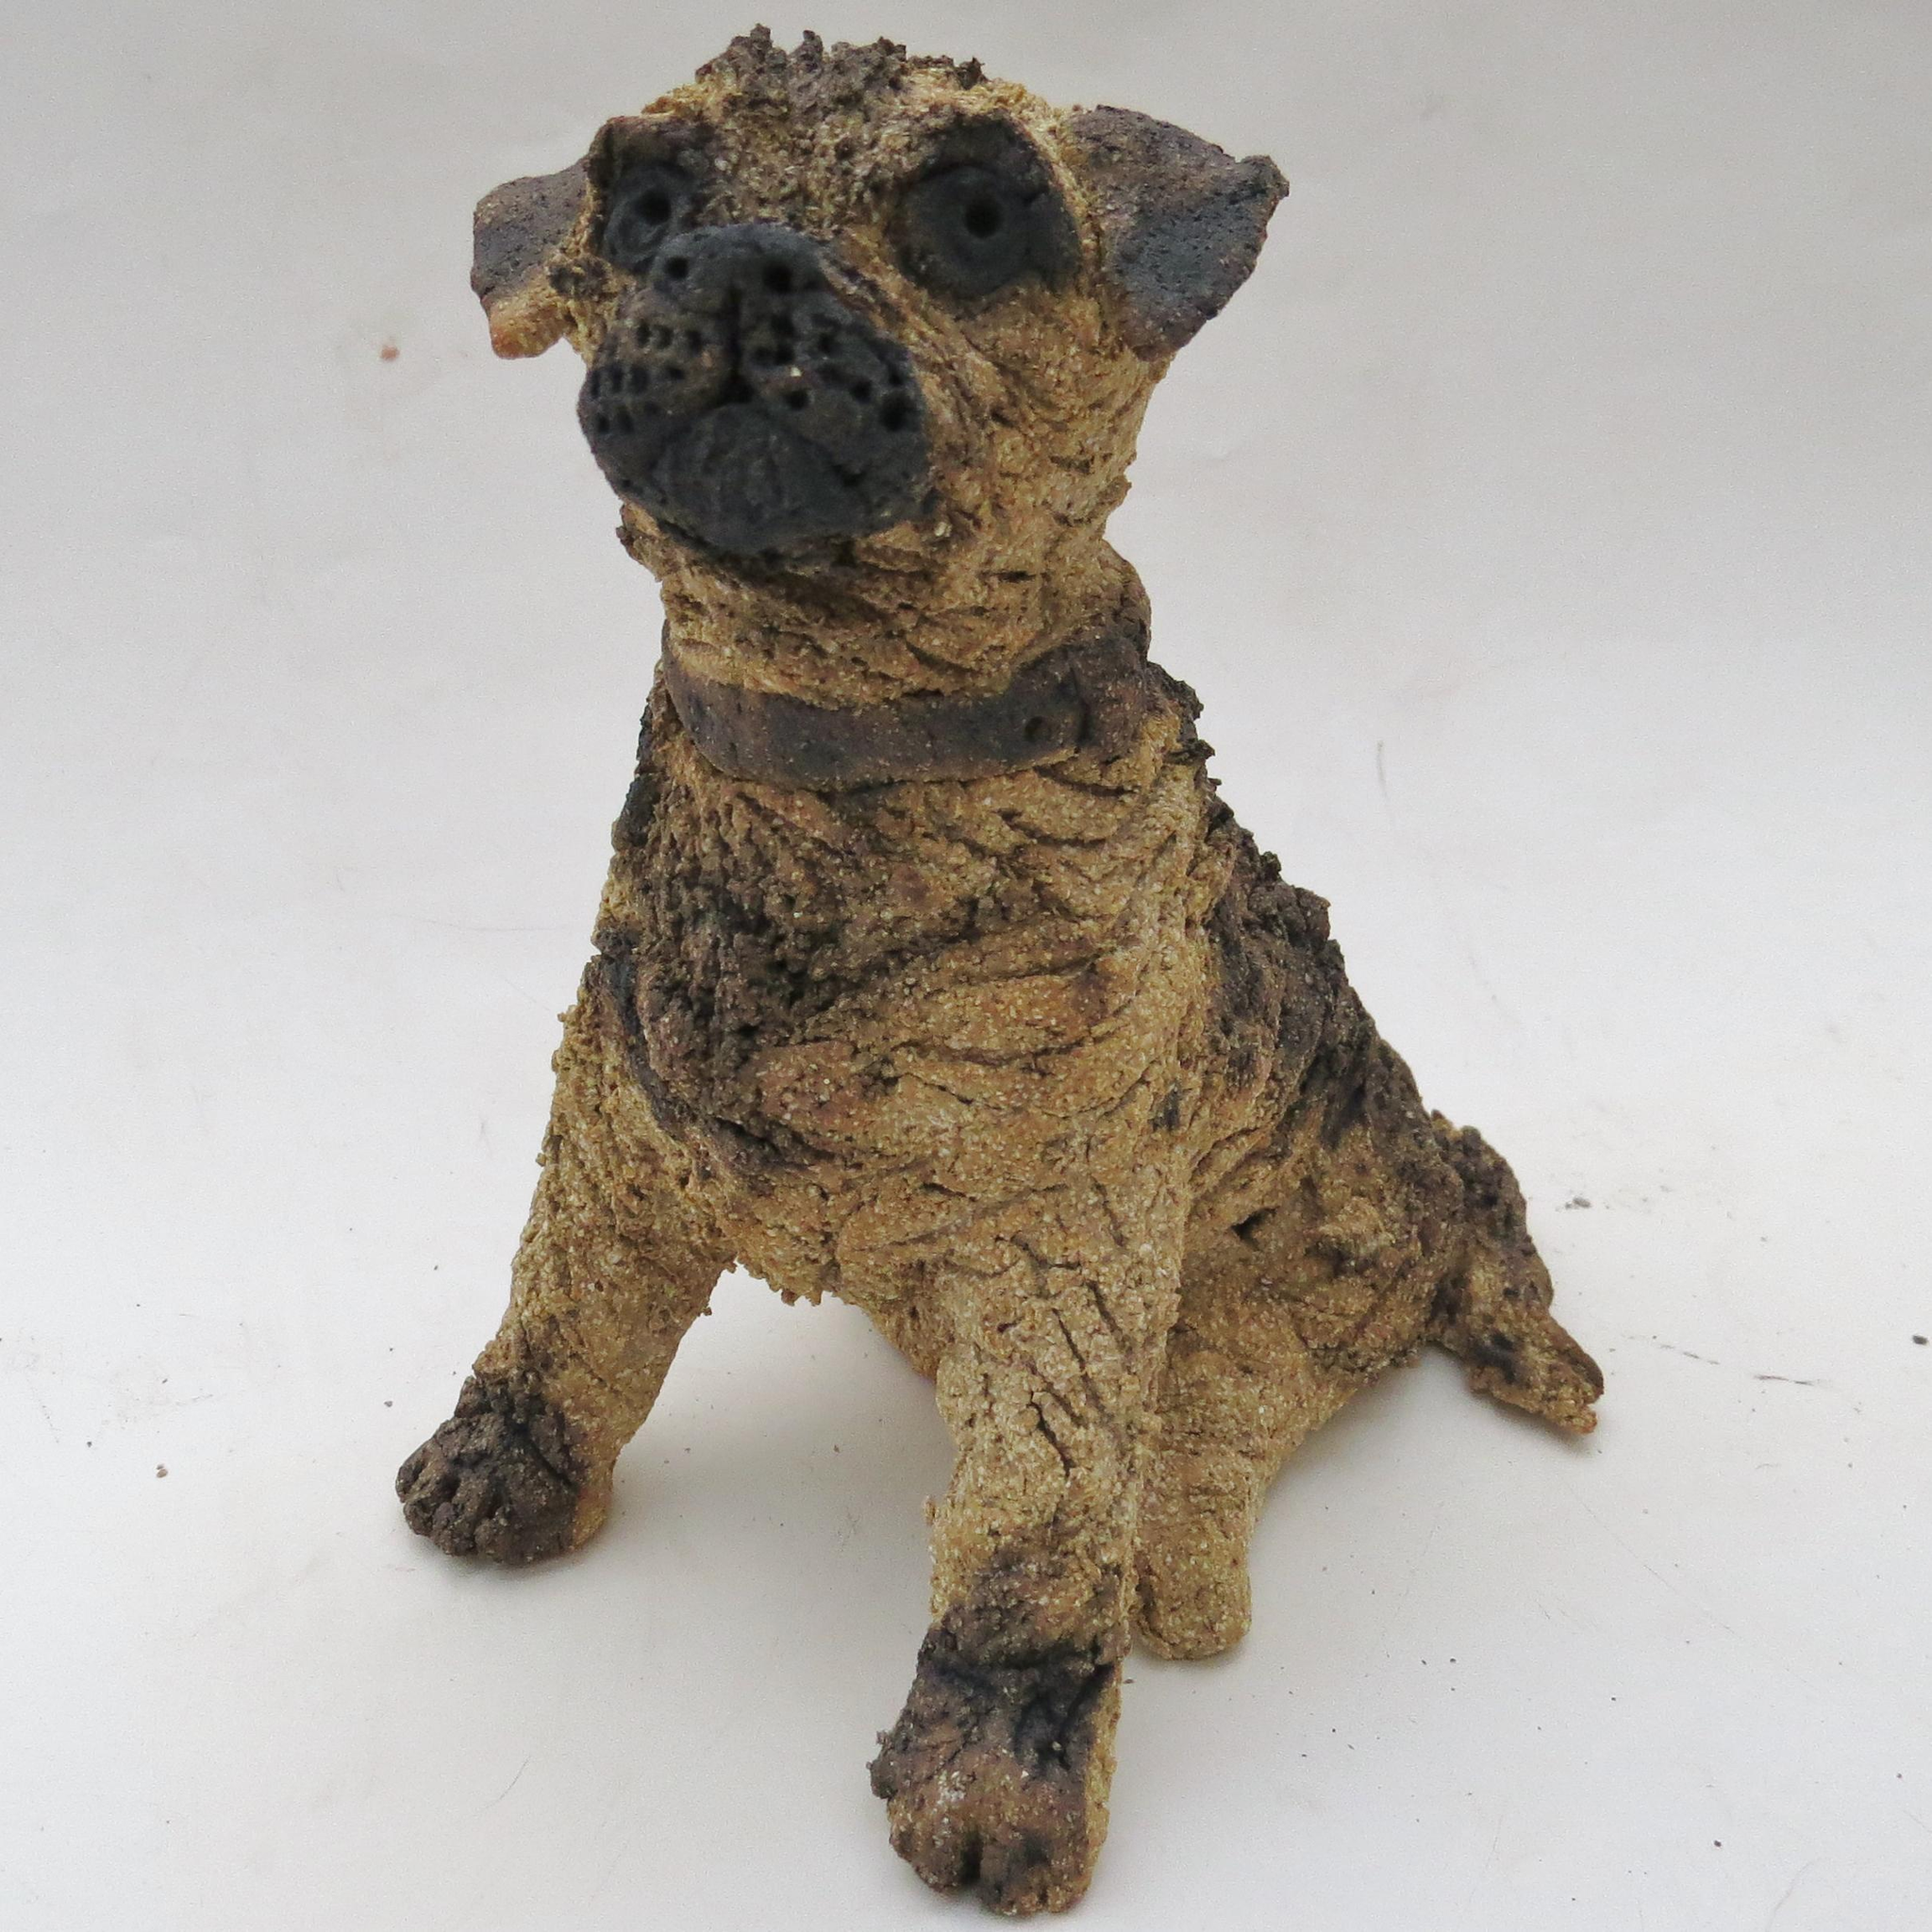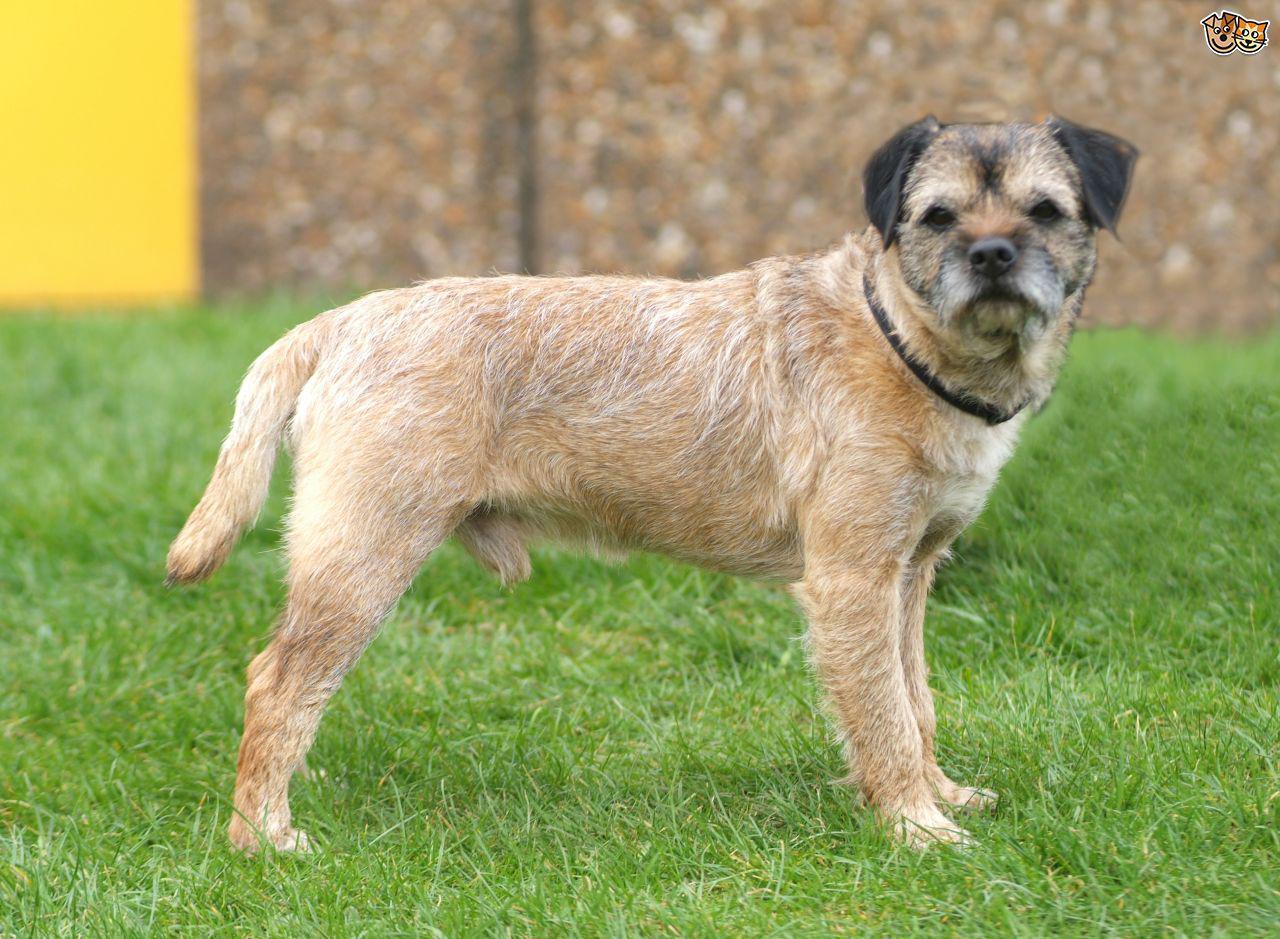The first image is the image on the left, the second image is the image on the right. Evaluate the accuracy of this statement regarding the images: "A dog has a front paw off the ground.". Is it true? Answer yes or no. No. The first image is the image on the left, the second image is the image on the right. For the images shown, is this caption "The left image features one dog in a sitting pose, and the right image shows a dog gazing at the camera and standing up on at least three feet." true? Answer yes or no. Yes. 